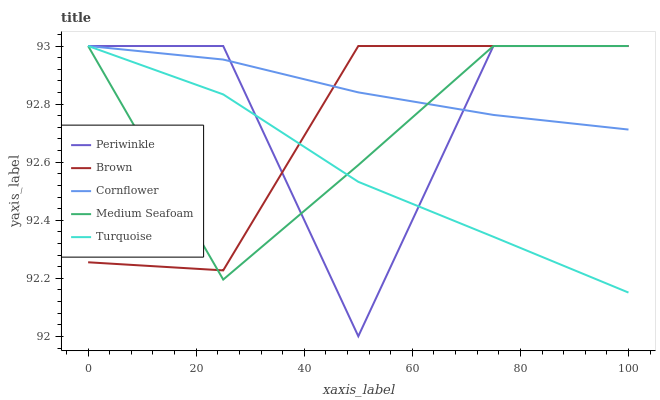Does Turquoise have the minimum area under the curve?
Answer yes or no. Yes. Does Cornflower have the maximum area under the curve?
Answer yes or no. Yes. Does Periwinkle have the minimum area under the curve?
Answer yes or no. No. Does Periwinkle have the maximum area under the curve?
Answer yes or no. No. Is Cornflower the smoothest?
Answer yes or no. Yes. Is Periwinkle the roughest?
Answer yes or no. Yes. Is Turquoise the smoothest?
Answer yes or no. No. Is Turquoise the roughest?
Answer yes or no. No. Does Turquoise have the lowest value?
Answer yes or no. No. Does Cornflower have the highest value?
Answer yes or no. Yes. 